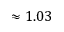Convert formula to latex. <formula><loc_0><loc_0><loc_500><loc_500>\approx 1 . 0 3</formula> 